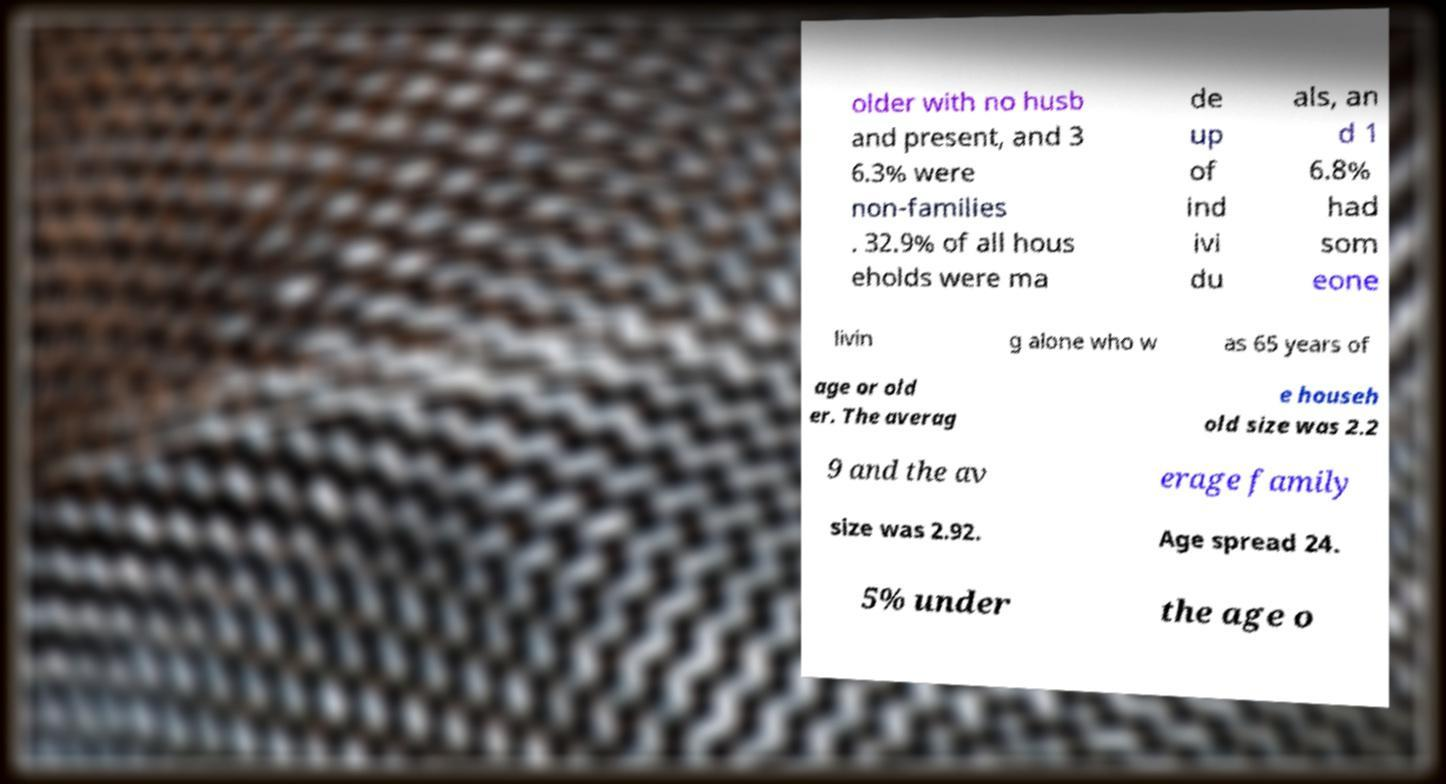Could you extract and type out the text from this image? older with no husb and present, and 3 6.3% were non-families . 32.9% of all hous eholds were ma de up of ind ivi du als, an d 1 6.8% had som eone livin g alone who w as 65 years of age or old er. The averag e househ old size was 2.2 9 and the av erage family size was 2.92. Age spread 24. 5% under the age o 